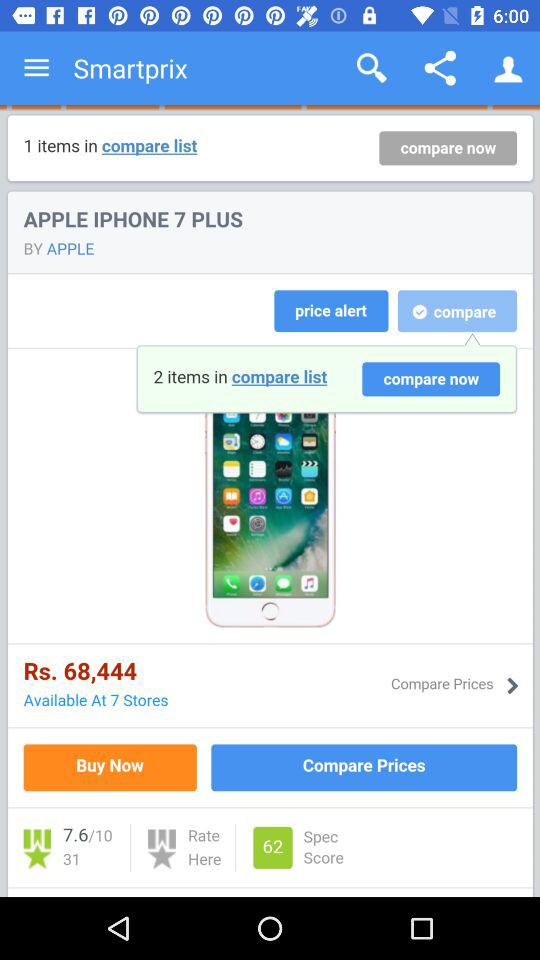What is the price of the Apple iPhone 7 Plus? The price is Rs. 68,444. 